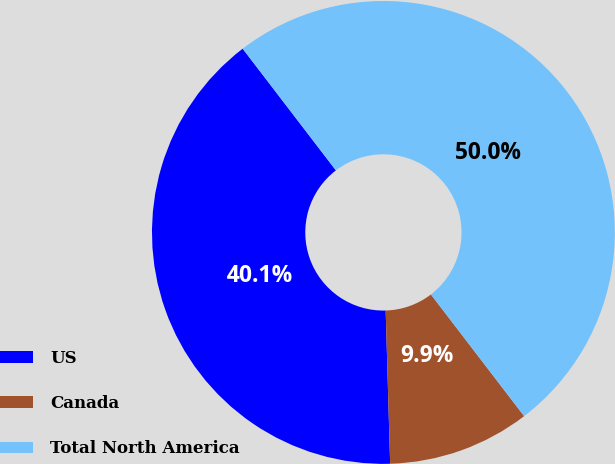Convert chart. <chart><loc_0><loc_0><loc_500><loc_500><pie_chart><fcel>US<fcel>Canada<fcel>Total North America<nl><fcel>40.06%<fcel>9.94%<fcel>50.0%<nl></chart> 